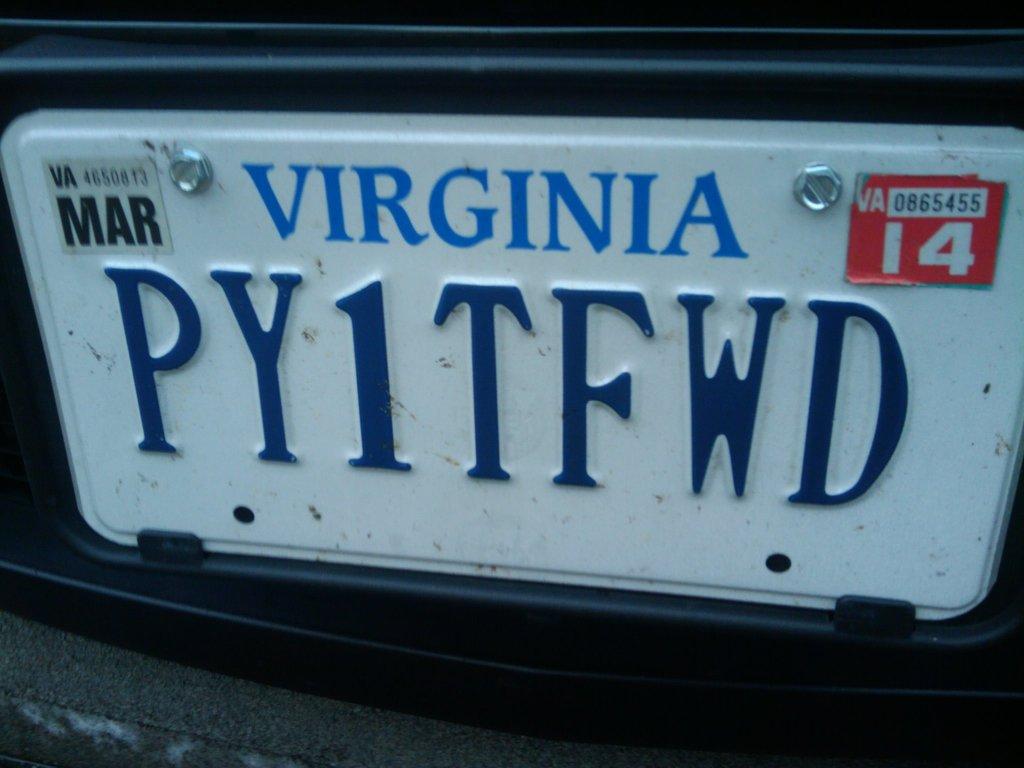What state is this license plate from?
Offer a very short reply. Virginia. What letter does the license plate start with?
Your answer should be very brief. P. 